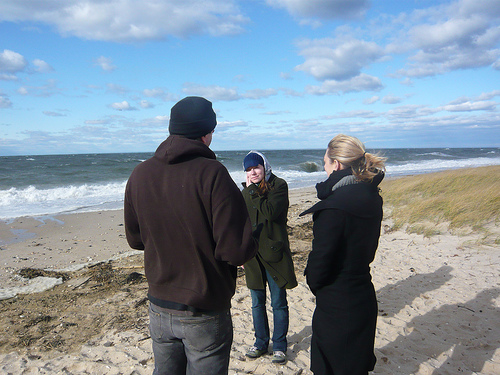<image>
Can you confirm if the woman is on the water? No. The woman is not positioned on the water. They may be near each other, but the woman is not supported by or resting on top of the water. Is the woman next to the water? No. The woman is not positioned next to the water. They are located in different areas of the scene. 